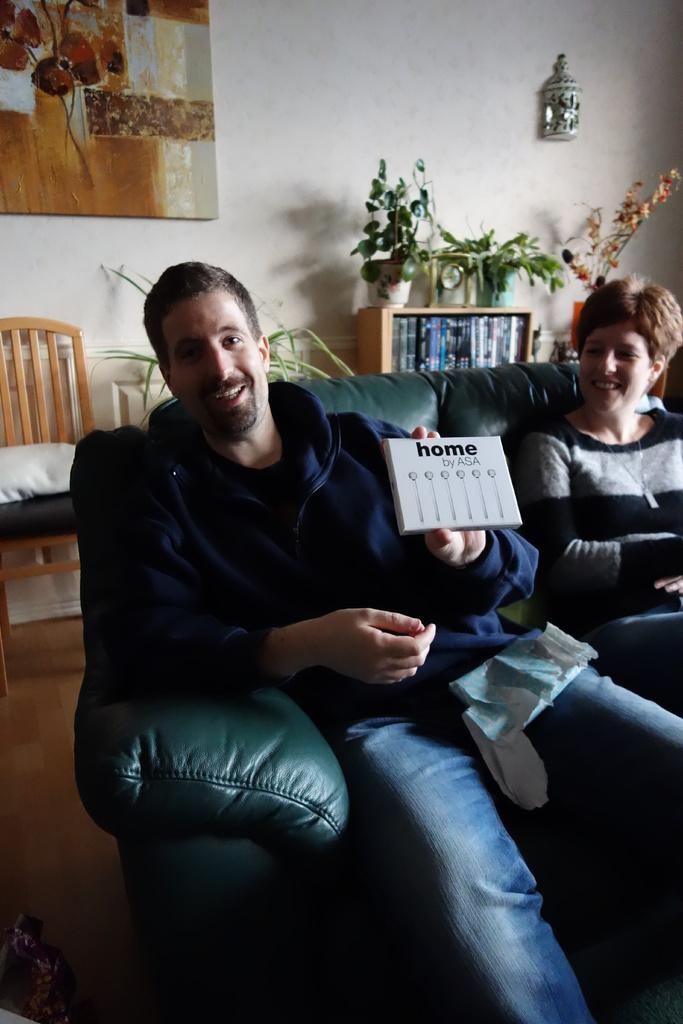Who can be seen in the image? There is a man and a woman in the image. What are they doing in the image? They are sitting on a sofa. What can be seen on the floor in the image? The floor is visible in the image. What is present in the background of the image? There is a wall, a frame, plants, and a chair in the background of the image. What type of root can be seen growing from the man's head in the image? There is no root growing from the man's head in the image; it is a photograph of a man and a woman sitting on a sofa. 